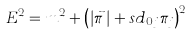<formula> <loc_0><loc_0><loc_500><loc_500>E ^ { 2 } = m ^ { 2 } + \left ( \left | \vec { \pi } \, \right | + s d _ { 0 j } \pi _ { j } \right ) ^ { 2 }</formula> 